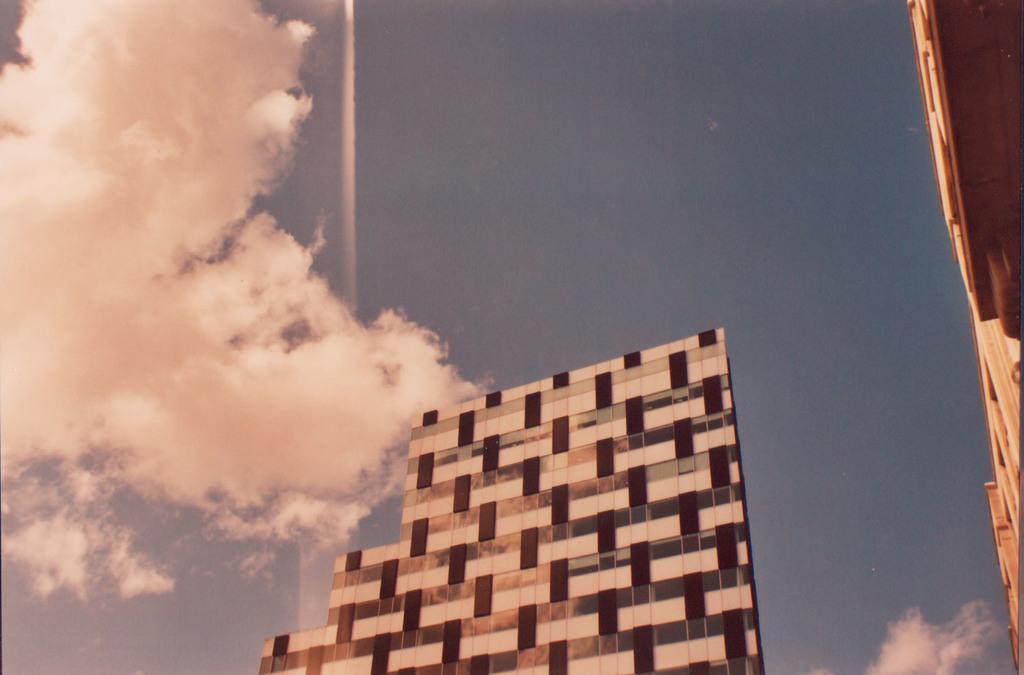Describe this image in one or two sentences. In this picture, we can see buildings, and the sky with clouds. 